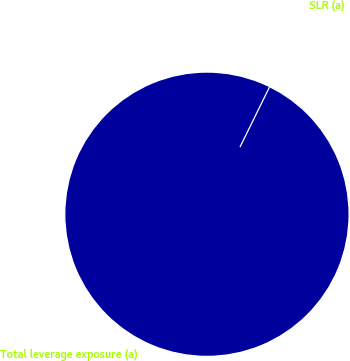Convert chart to OTSL. <chart><loc_0><loc_0><loc_500><loc_500><pie_chart><fcel>Total leverage exposure (a)<fcel>SLR (a)<nl><fcel>100.0%<fcel>0.0%<nl></chart> 